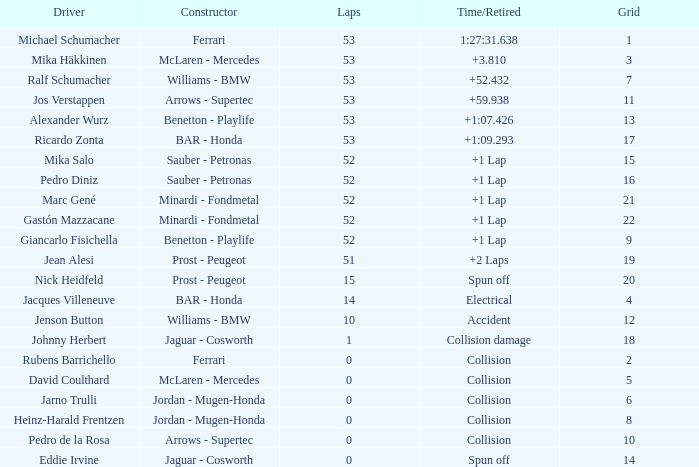What was the total number of laps completed by ricardo zonta? 53.0. 